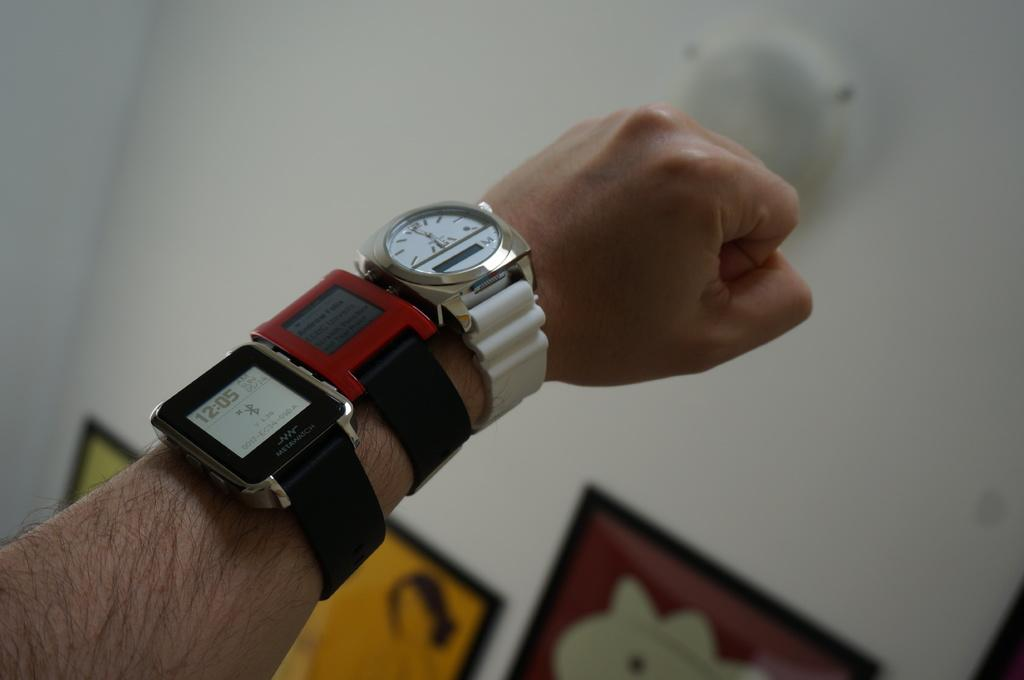<image>
Offer a succinct explanation of the picture presented. Person wearing three watches with one saying Metawatch on it. 